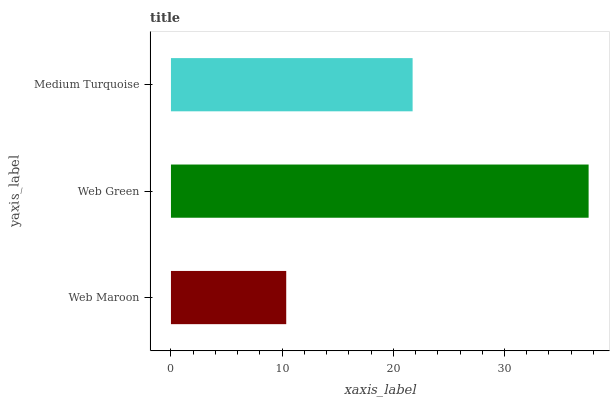Is Web Maroon the minimum?
Answer yes or no. Yes. Is Web Green the maximum?
Answer yes or no. Yes. Is Medium Turquoise the minimum?
Answer yes or no. No. Is Medium Turquoise the maximum?
Answer yes or no. No. Is Web Green greater than Medium Turquoise?
Answer yes or no. Yes. Is Medium Turquoise less than Web Green?
Answer yes or no. Yes. Is Medium Turquoise greater than Web Green?
Answer yes or no. No. Is Web Green less than Medium Turquoise?
Answer yes or no. No. Is Medium Turquoise the high median?
Answer yes or no. Yes. Is Medium Turquoise the low median?
Answer yes or no. Yes. Is Web Maroon the high median?
Answer yes or no. No. Is Web Green the low median?
Answer yes or no. No. 